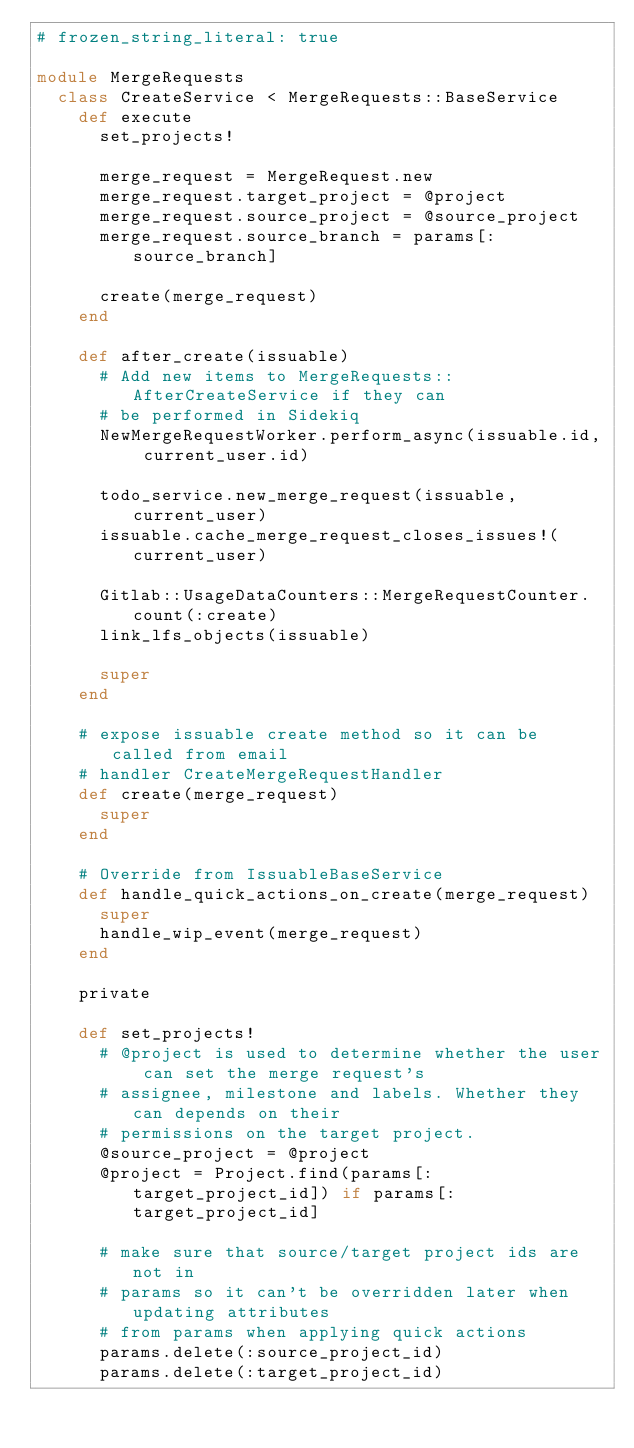<code> <loc_0><loc_0><loc_500><loc_500><_Ruby_># frozen_string_literal: true

module MergeRequests
  class CreateService < MergeRequests::BaseService
    def execute
      set_projects!

      merge_request = MergeRequest.new
      merge_request.target_project = @project
      merge_request.source_project = @source_project
      merge_request.source_branch = params[:source_branch]

      create(merge_request)
    end

    def after_create(issuable)
      # Add new items to MergeRequests::AfterCreateService if they can
      # be performed in Sidekiq
      NewMergeRequestWorker.perform_async(issuable.id, current_user.id)

      todo_service.new_merge_request(issuable, current_user)
      issuable.cache_merge_request_closes_issues!(current_user)

      Gitlab::UsageDataCounters::MergeRequestCounter.count(:create)
      link_lfs_objects(issuable)

      super
    end

    # expose issuable create method so it can be called from email
    # handler CreateMergeRequestHandler
    def create(merge_request)
      super
    end

    # Override from IssuableBaseService
    def handle_quick_actions_on_create(merge_request)
      super
      handle_wip_event(merge_request)
    end

    private

    def set_projects!
      # @project is used to determine whether the user can set the merge request's
      # assignee, milestone and labels. Whether they can depends on their
      # permissions on the target project.
      @source_project = @project
      @project = Project.find(params[:target_project_id]) if params[:target_project_id]

      # make sure that source/target project ids are not in
      # params so it can't be overridden later when updating attributes
      # from params when applying quick actions
      params.delete(:source_project_id)
      params.delete(:target_project_id)
</code> 